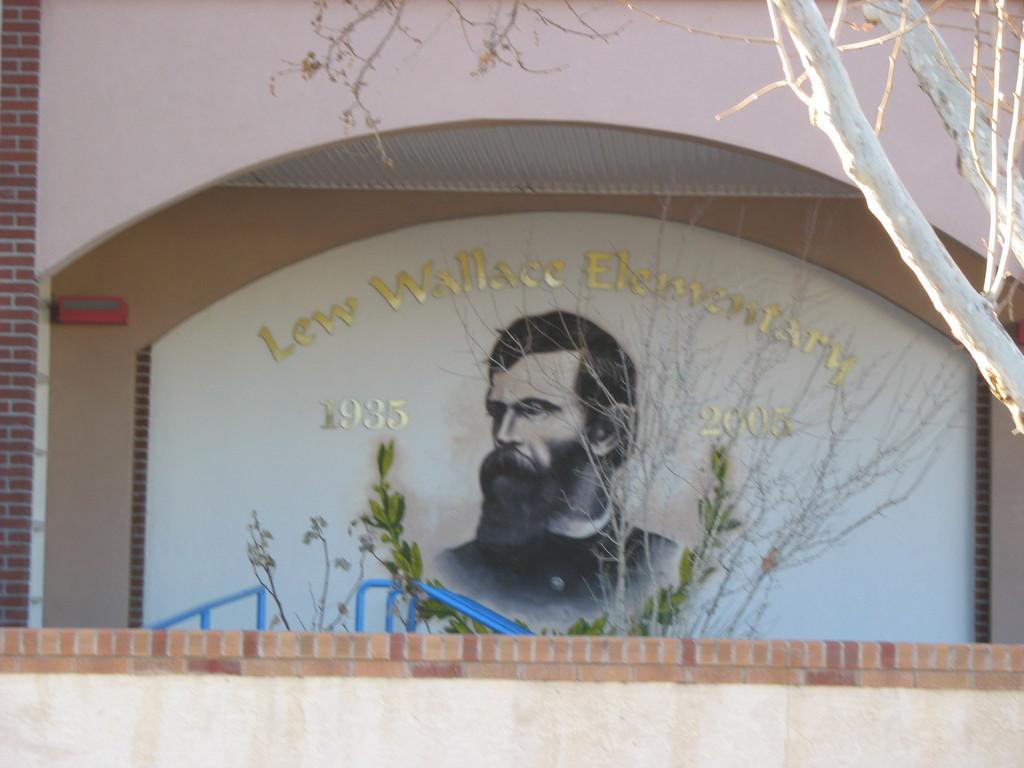Please provide a concise description of this image. Here we can see a painting of a person on the wall. And there are plants. 